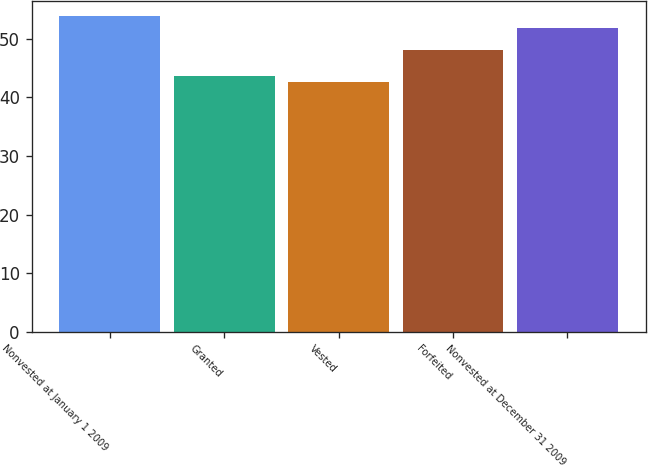Convert chart to OTSL. <chart><loc_0><loc_0><loc_500><loc_500><bar_chart><fcel>Nonvested at January 1 2009<fcel>Granted<fcel>Vested<fcel>Forfeited<fcel>Nonvested at December 31 2009<nl><fcel>53.83<fcel>43.7<fcel>42.58<fcel>48.08<fcel>51.83<nl></chart> 